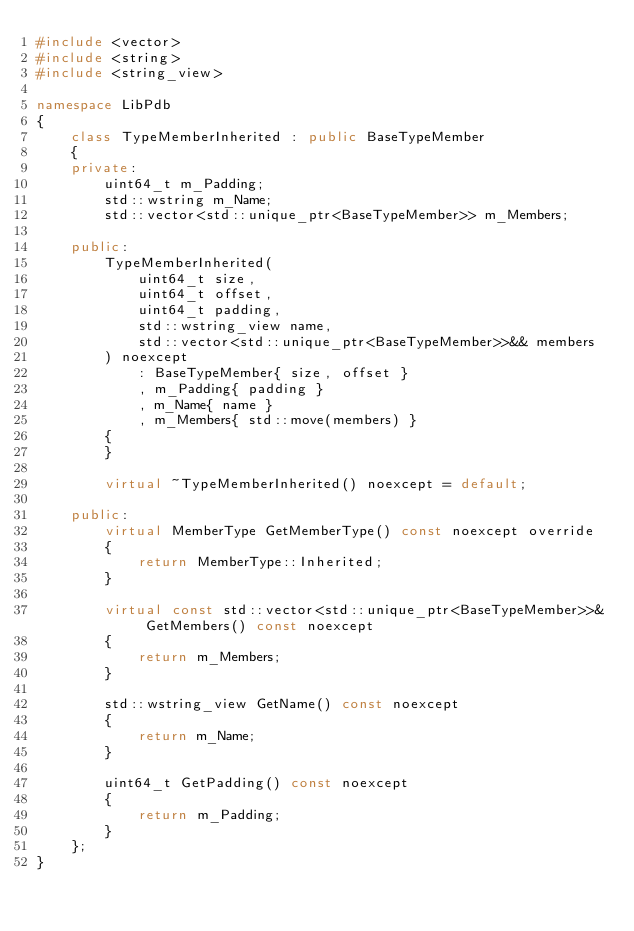<code> <loc_0><loc_0><loc_500><loc_500><_C++_>#include <vector>
#include <string>
#include <string_view>

namespace LibPdb
{
    class TypeMemberInherited : public BaseTypeMember
    {
    private:
        uint64_t m_Padding;
        std::wstring m_Name;
        std::vector<std::unique_ptr<BaseTypeMember>> m_Members;

    public:
        TypeMemberInherited(
            uint64_t size,
            uint64_t offset,
            uint64_t padding,
            std::wstring_view name,
            std::vector<std::unique_ptr<BaseTypeMember>>&& members
        ) noexcept
            : BaseTypeMember{ size, offset }
            , m_Padding{ padding }
            , m_Name{ name }
            , m_Members{ std::move(members) }
        {
        }

        virtual ~TypeMemberInherited() noexcept = default;

    public:
        virtual MemberType GetMemberType() const noexcept override
        {
            return MemberType::Inherited;
        }

        virtual const std::vector<std::unique_ptr<BaseTypeMember>>& GetMembers() const noexcept
        {
            return m_Members;
        }

        std::wstring_view GetName() const noexcept
        {
            return m_Name;
        }

        uint64_t GetPadding() const noexcept
        {
            return m_Padding;
        }
    };
}
</code> 